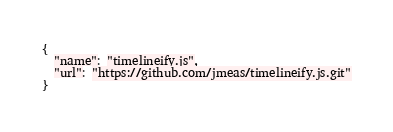Convert code to text. <code><loc_0><loc_0><loc_500><loc_500><_JavaScript_>{
  "name": "timelineify.js",
  "url": "https://github.com/jmeas/timelineify.js.git"
}
</code> 